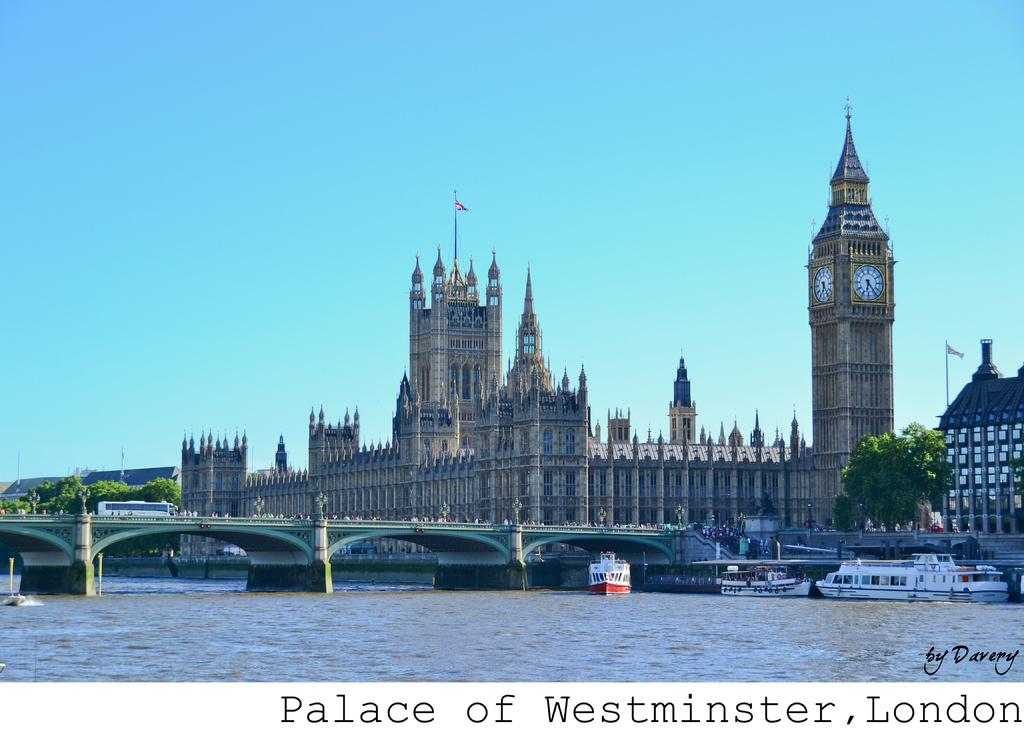What type of structure is present in the image? There is a building in the image. What can be seen in the middle of the image? There is a bridge in the middle of the image. What is at the bottom of the image? There is water at the bottom of the image. How many boats are on the water? There are three boats on the water. What is visible at the top of the image? There is a sky visible at the top of the image. Can you tell me how many trees are in the flock depicted in the image? There is no flock or trees present in the image; it features a building, a bridge, water, boats, and a sky. 